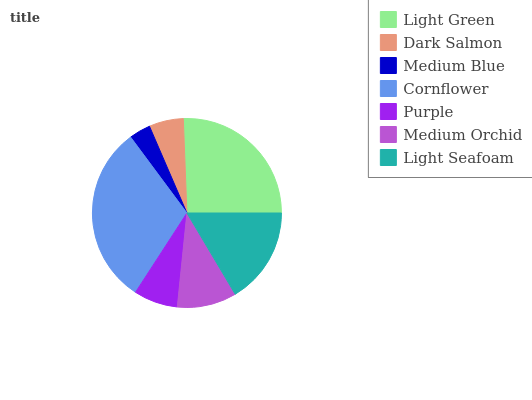Is Medium Blue the minimum?
Answer yes or no. Yes. Is Cornflower the maximum?
Answer yes or no. Yes. Is Dark Salmon the minimum?
Answer yes or no. No. Is Dark Salmon the maximum?
Answer yes or no. No. Is Light Green greater than Dark Salmon?
Answer yes or no. Yes. Is Dark Salmon less than Light Green?
Answer yes or no. Yes. Is Dark Salmon greater than Light Green?
Answer yes or no. No. Is Light Green less than Dark Salmon?
Answer yes or no. No. Is Medium Orchid the high median?
Answer yes or no. Yes. Is Medium Orchid the low median?
Answer yes or no. Yes. Is Light Green the high median?
Answer yes or no. No. Is Light Green the low median?
Answer yes or no. No. 